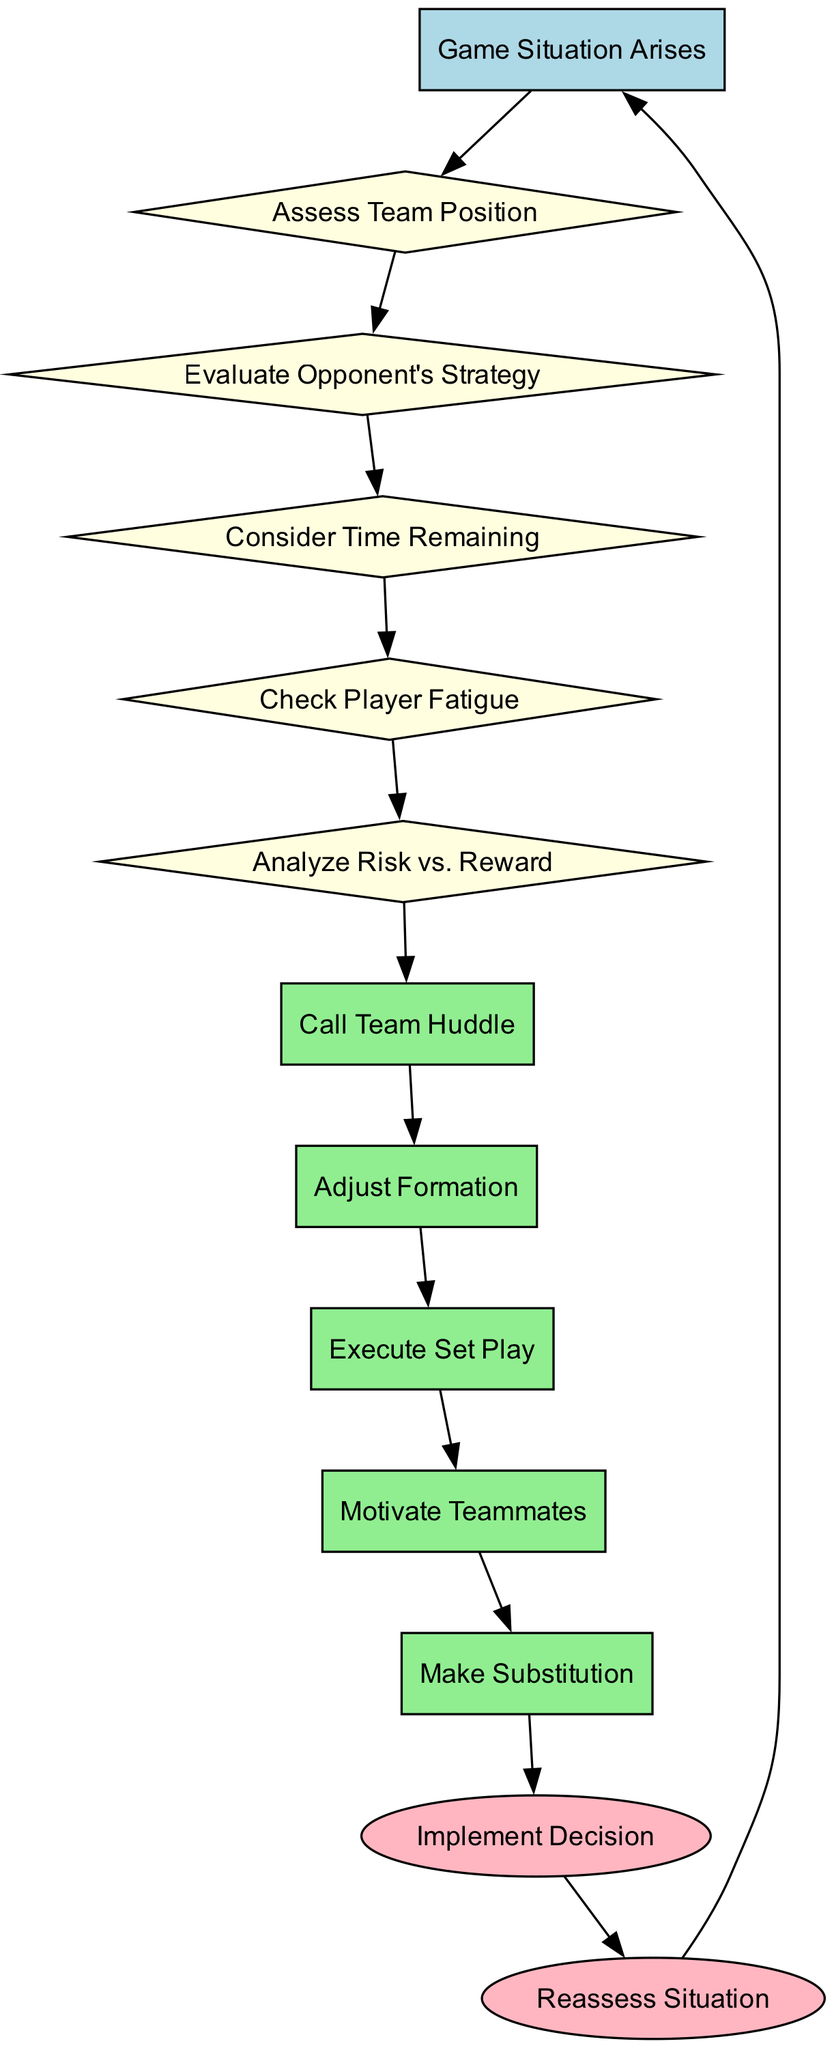What is the first step in the decision-making process? The diagram starts with the node "Game Situation Arises," which indicates the beginning of the decision-making process.
Answer: Game Situation Arises How many decision nodes are in the flowchart? There are five decision nodes listed in the diagram: "Assess Team Position," "Evaluate Opponent's Strategy," "Consider Time Remaining," "Check Player Fatigue," and "Analyze Risk vs. Reward." Counting these gives a total of five.
Answer: 5 What follows after "Motivate Teammates"? According to the flowchart, after "Motivate Teammates," the next action is "Make Substitution." This shows the progression from motivating teammates to making a substitution.
Answer: Make Substitution What indicates the end of the decision-making process? The flowchart contains two end nodes: "Implement Decision" and "Reassess Situation." These nodes signify the conclusion of the decision-making process.
Answer: Implement Decision, Reassess Situation Which action follows the decision to call a team huddle? Following the action "Call Team Huddle," the next step in the flowchart is "Adjust Formation." This shows the immediate response after gathering the team.
Answer: Adjust Formation What type of node is "Check Player Fatigue"? "Check Player Fatigue" is categorized as a decision node, as it requires evaluating a specific condition (player fatigue) before proceeding to further actions.
Answer: Decision Node How does the flowchart handle recurrent situations? The flowchart shows a cycle with "Reassess Situation" leading back to "Game Situation Arises," indicating that the decision-making process can restart based on new game situations.
Answer: Cycle Which action is taken right after assessing the team position? After "Assess Team Position," the flowchart dictates that the next step is "Evaluate Opponent's Strategy," indicating a need to understand both team and opponent positions.
Answer: Evaluate Opponent's Strategy What is the connection between "Analyze Risk vs. Reward" and the end nodes? "Analyze Risk vs. Reward" leads to the action "Call Team Huddle," which subsequently leads to other actions before ultimately reaching the end nodes, showing how evaluations influence decisions.
Answer: Call Team Huddle 